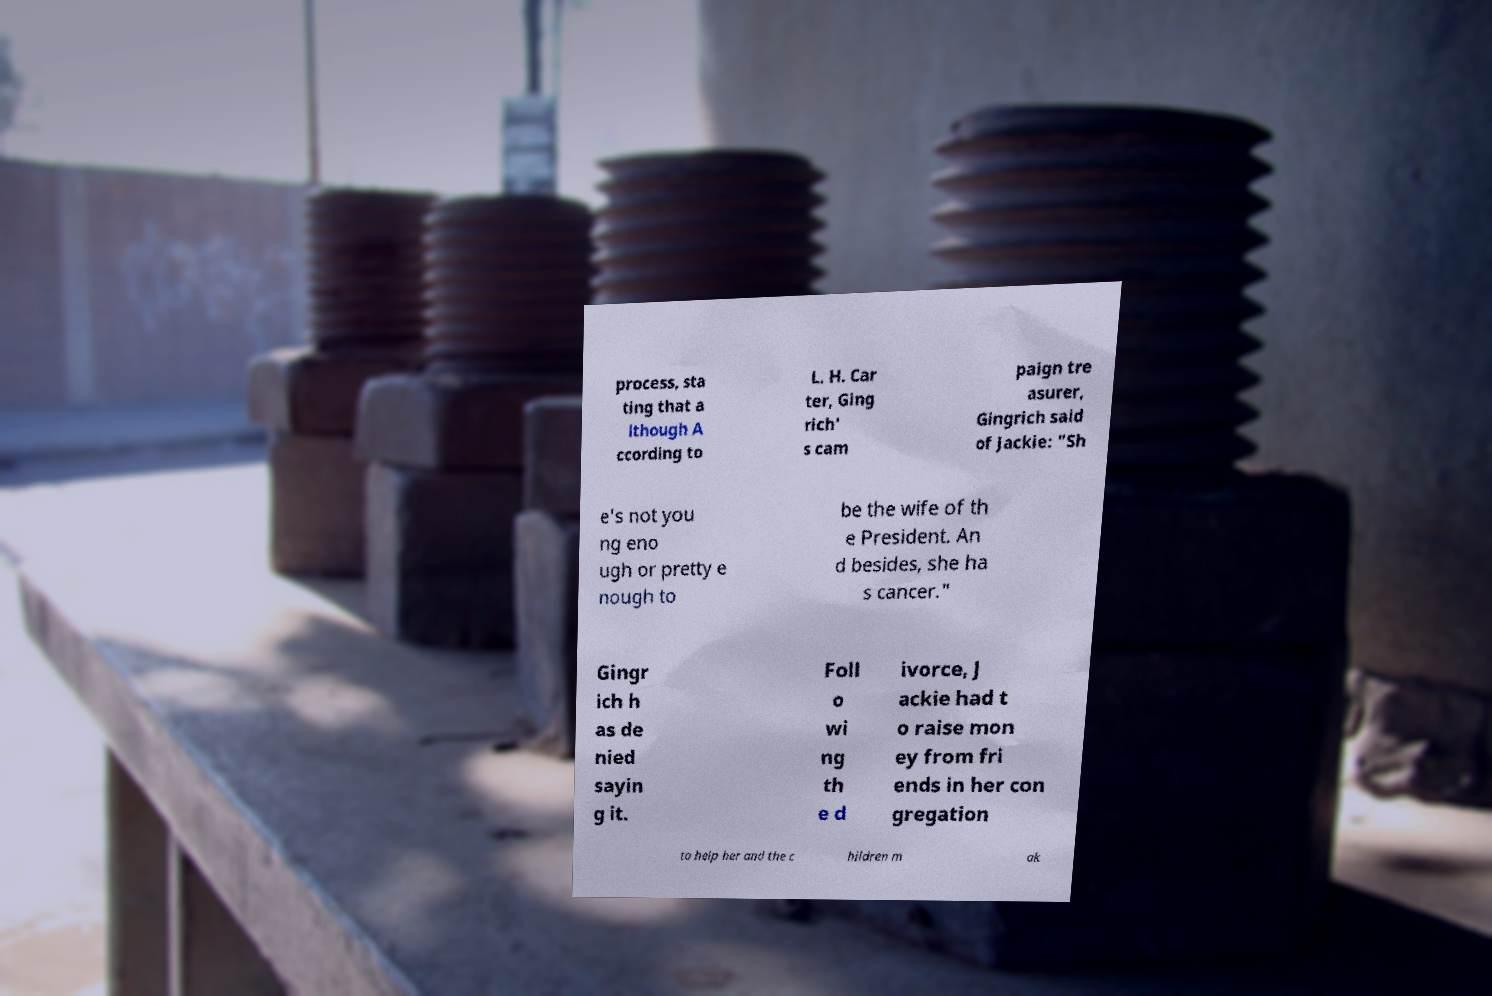Please identify and transcribe the text found in this image. process, sta ting that a lthough A ccording to L. H. Car ter, Ging rich' s cam paign tre asurer, Gingrich said of Jackie: "Sh e's not you ng eno ugh or pretty e nough to be the wife of th e President. An d besides, she ha s cancer." Gingr ich h as de nied sayin g it. Foll o wi ng th e d ivorce, J ackie had t o raise mon ey from fri ends in her con gregation to help her and the c hildren m ak 